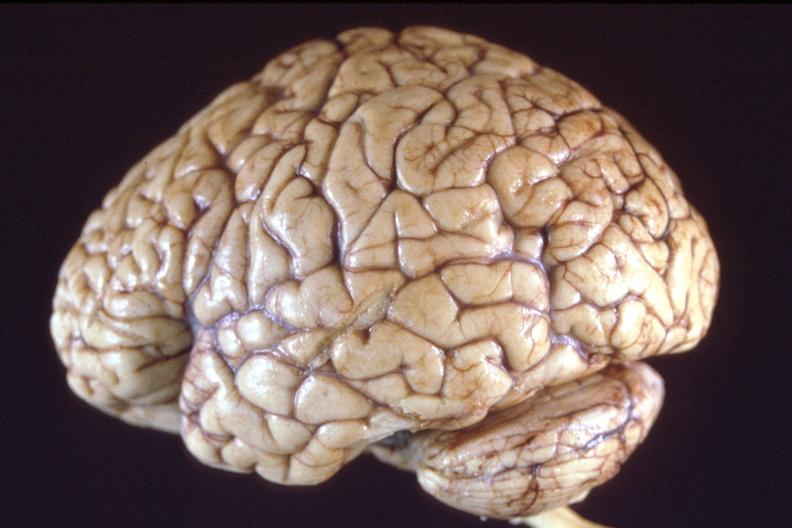what is present?
Answer the question using a single word or phrase. Nervous 